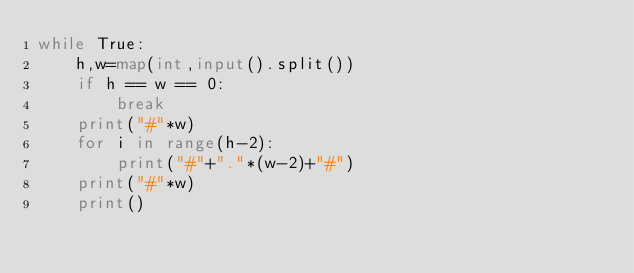Convert code to text. <code><loc_0><loc_0><loc_500><loc_500><_Python_>while True:
    h,w=map(int,input().split())
    if h == w == 0:
        break
    print("#"*w)
    for i in range(h-2):
        print("#"+"."*(w-2)+"#")
    print("#"*w)
    print()
</code> 